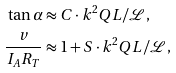Convert formula to latex. <formula><loc_0><loc_0><loc_500><loc_500>\tan \alpha & \approx C \cdot k ^ { 2 } Q L / \mathcal { L } , \\ \frac { v } { I _ { A } R _ { T } } & \approx 1 + S \cdot k ^ { 2 } Q L / \mathcal { L } ,</formula> 